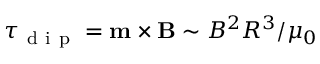<formula> <loc_0><loc_0><loc_500><loc_500>\tau _ { d i p } = m \times B \sim B ^ { 2 } R ^ { 3 } / \mu _ { 0 }</formula> 